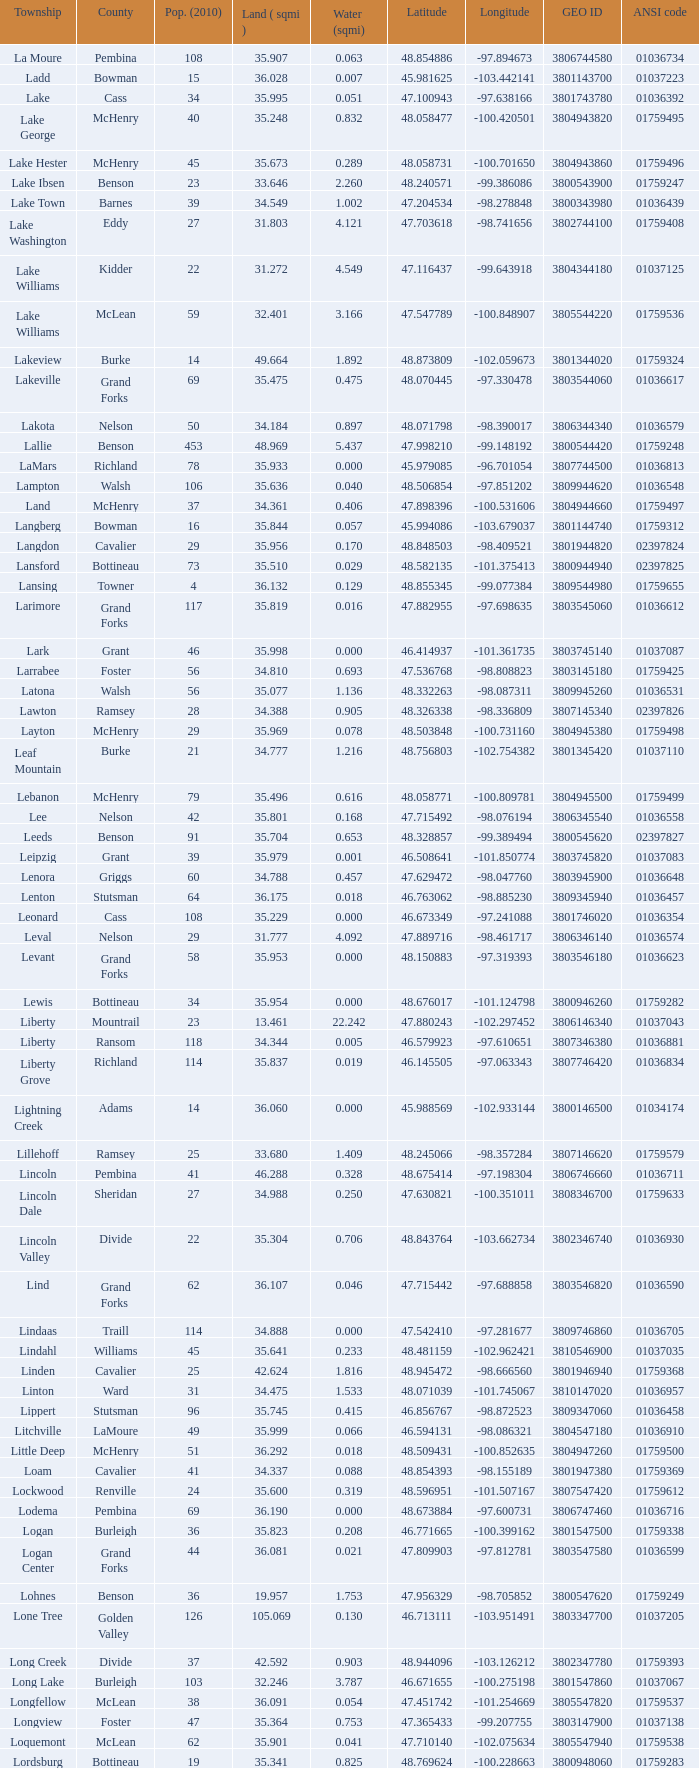What is the latitudinal position when the population in 2010 is 24 and water amount is greater than None. 